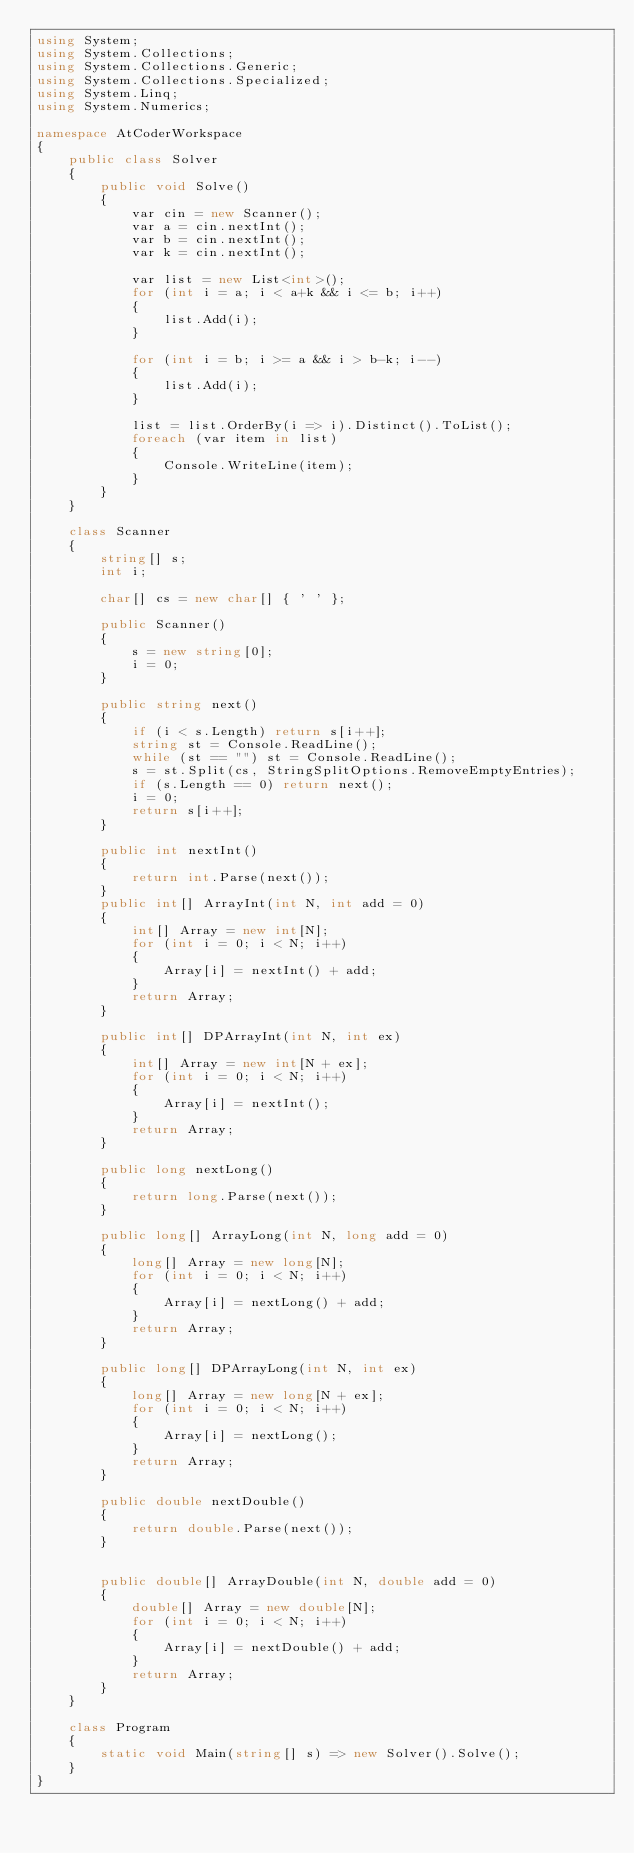Convert code to text. <code><loc_0><loc_0><loc_500><loc_500><_C#_>using System;
using System.Collections;
using System.Collections.Generic;
using System.Collections.Specialized;
using System.Linq;
using System.Numerics;

namespace AtCoderWorkspace
{
    public class Solver
    {
        public void Solve()
        {
            var cin = new Scanner();
            var a = cin.nextInt();
            var b = cin.nextInt();
            var k = cin.nextInt();

            var list = new List<int>();
            for (int i = a; i < a+k && i <= b; i++)
            {
                list.Add(i);
            }

            for (int i = b; i >= a && i > b-k; i--)
            {
                list.Add(i);
            }

            list = list.OrderBy(i => i).Distinct().ToList();
            foreach (var item in list)
            {
                Console.WriteLine(item);
            }
        }
    }

    class Scanner
    {
        string[] s;
        int i;

        char[] cs = new char[] { ' ' };

        public Scanner()
        {
            s = new string[0];
            i = 0;
        }

        public string next()
        {
            if (i < s.Length) return s[i++];
            string st = Console.ReadLine();
            while (st == "") st = Console.ReadLine();
            s = st.Split(cs, StringSplitOptions.RemoveEmptyEntries);
            if (s.Length == 0) return next();
            i = 0;
            return s[i++];
        }

        public int nextInt()
        {
            return int.Parse(next());
        }
        public int[] ArrayInt(int N, int add = 0)
        {
            int[] Array = new int[N];
            for (int i = 0; i < N; i++)
            {
                Array[i] = nextInt() + add;
            }
            return Array;
        }

        public int[] DPArrayInt(int N, int ex)
        {
            int[] Array = new int[N + ex];
            for (int i = 0; i < N; i++)
            {
                Array[i] = nextInt();
            }
            return Array;
        }

        public long nextLong()
        {
            return long.Parse(next());
        }

        public long[] ArrayLong(int N, long add = 0)
        {
            long[] Array = new long[N];
            for (int i = 0; i < N; i++)
            {
                Array[i] = nextLong() + add;
            }
            return Array;
        }

        public long[] DPArrayLong(int N, int ex)
        {
            long[] Array = new long[N + ex];
            for (int i = 0; i < N; i++)
            {
                Array[i] = nextLong();
            }
            return Array;
        }

        public double nextDouble()
        {
            return double.Parse(next());
        }


        public double[] ArrayDouble(int N, double add = 0)
        {
            double[] Array = new double[N];
            for (int i = 0; i < N; i++)
            {
                Array[i] = nextDouble() + add;
            }
            return Array;
        }
    }

    class Program
    {
        static void Main(string[] s) => new Solver().Solve();
    }
}
</code> 